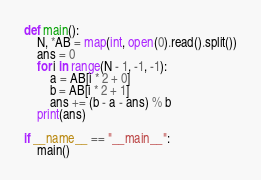<code> <loc_0><loc_0><loc_500><loc_500><_Python_>def main():
    N, *AB = map(int, open(0).read().split())
    ans = 0
    for i in range(N - 1, -1, -1):
        a = AB[i * 2 + 0]
        b = AB[i * 2 + 1]
        ans += (b - a - ans) % b
    print(ans)

if __name__ == "__main__":
    main()
</code> 